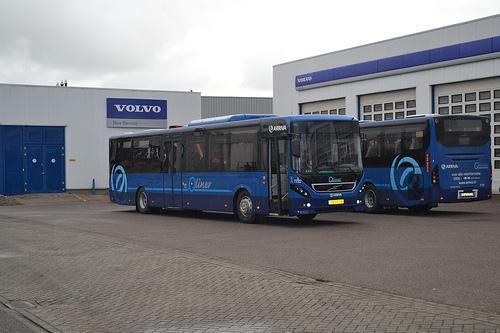How many busses?
Give a very brief answer. 2. How many garage doors?
Give a very brief answer. 3. 